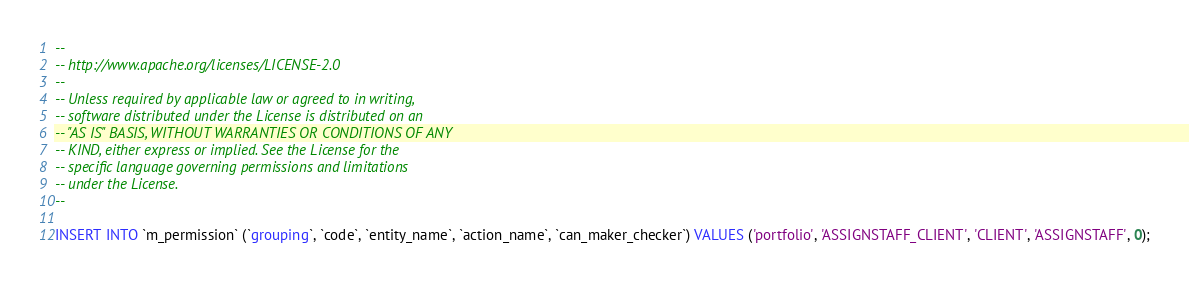Convert code to text. <code><loc_0><loc_0><loc_500><loc_500><_SQL_>--
-- http://www.apache.org/licenses/LICENSE-2.0
--
-- Unless required by applicable law or agreed to in writing,
-- software distributed under the License is distributed on an
-- "AS IS" BASIS, WITHOUT WARRANTIES OR CONDITIONS OF ANY
-- KIND, either express or implied. See the License for the
-- specific language governing permissions and limitations
-- under the License.
--

INSERT INTO `m_permission` (`grouping`, `code`, `entity_name`, `action_name`, `can_maker_checker`) VALUES ('portfolio', 'ASSIGNSTAFF_CLIENT', 'CLIENT', 'ASSIGNSTAFF', 0);</code> 